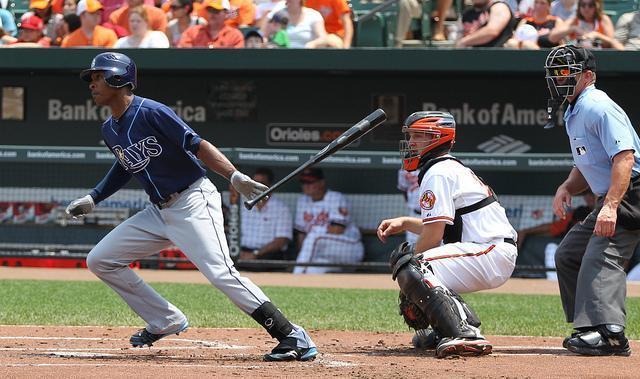How many people can be seen?
Give a very brief answer. 8. How many animals have a bird on their back?
Give a very brief answer. 0. 